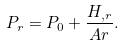Convert formula to latex. <formula><loc_0><loc_0><loc_500><loc_500>P _ { r } = P _ { 0 } + \frac { H _ { , r } } { A r } .</formula> 